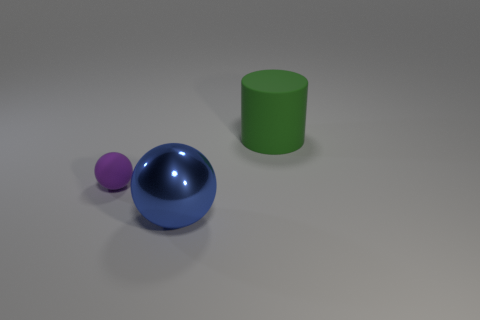Add 3 tiny purple matte spheres. How many objects exist? 6 Subtract all cylinders. How many objects are left? 2 Subtract all blue shiny objects. Subtract all large rubber cylinders. How many objects are left? 1 Add 1 blue metallic balls. How many blue metallic balls are left? 2 Add 1 large shiny cylinders. How many large shiny cylinders exist? 1 Subtract 0 cyan balls. How many objects are left? 3 